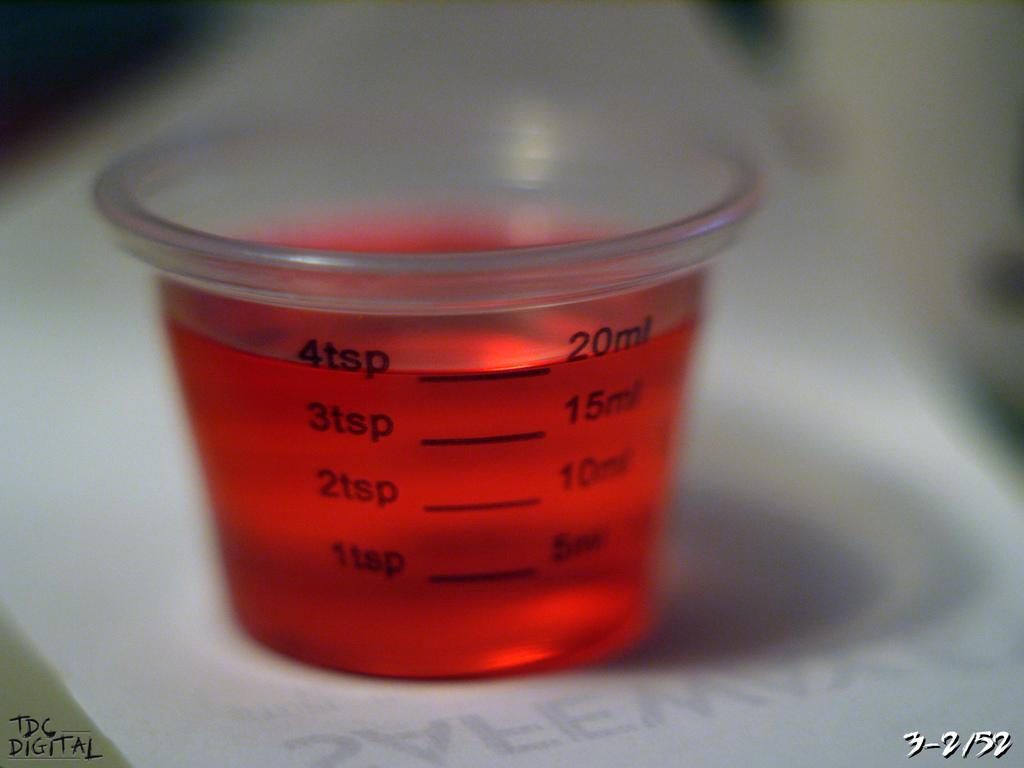<image>
Present a compact description of the photo's key features. A cup of red medicine sits in a medicine cup marked up to 4tsp or 20ml 